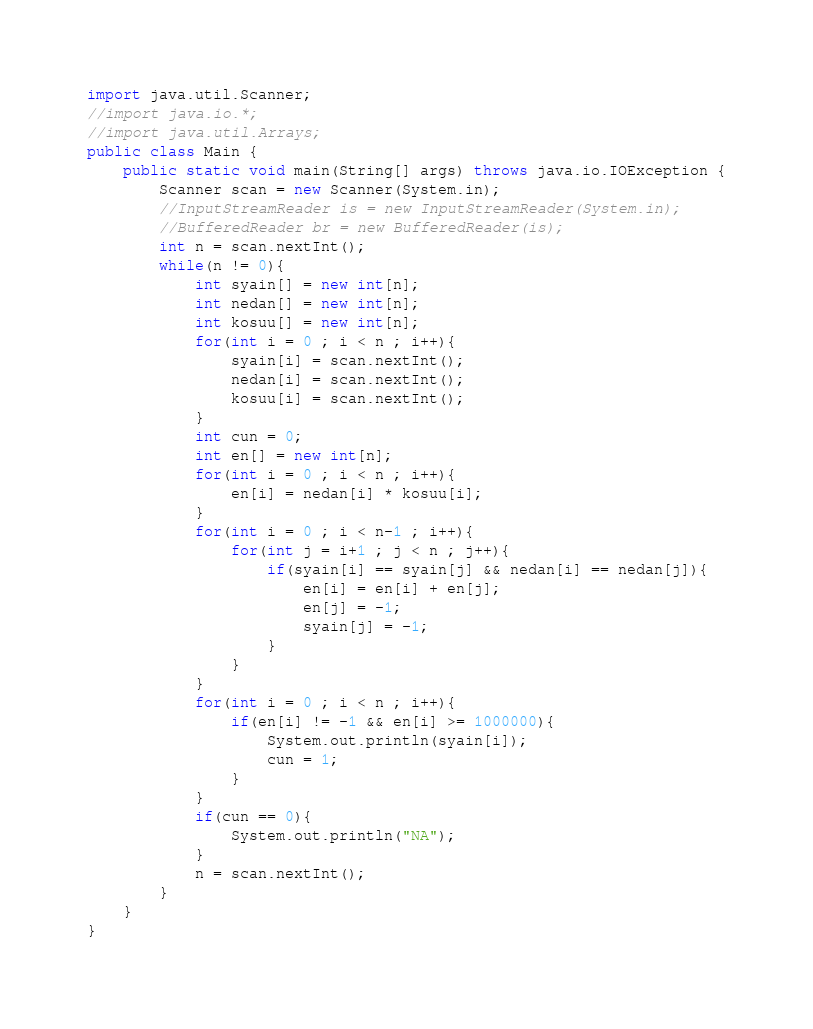<code> <loc_0><loc_0><loc_500><loc_500><_Java_>import java.util.Scanner;
//import java.io.*;
//import java.util.Arrays;
public class Main {
	public static void main(String[] args) throws java.io.IOException {
		Scanner scan = new Scanner(System.in);
		//InputStreamReader is = new InputStreamReader(System.in);
		//BufferedReader br = new BufferedReader(is);
		int n = scan.nextInt();
		while(n != 0){
			int syain[] = new int[n];
			int nedan[] = new int[n];
			int kosuu[] = new int[n];
			for(int i = 0 ; i < n ; i++){
				syain[i] = scan.nextInt();
				nedan[i] = scan.nextInt();
				kosuu[i] = scan.nextInt();
			}
			int cun = 0;
			int en[] = new int[n];
			for(int i = 0 ; i < n ; i++){
				en[i] = nedan[i] * kosuu[i];
			}
			for(int i = 0 ; i < n-1 ; i++){
				for(int j = i+1 ; j < n ; j++){
					if(syain[i] == syain[j] && nedan[i] == nedan[j]){
						en[i] = en[i] + en[j];
						en[j] = -1;
						syain[j] = -1;
					}
				}
			}
			for(int i = 0 ; i < n ; i++){
				if(en[i] != -1 && en[i] >= 1000000){
					System.out.println(syain[i]);
					cun = 1;
				}
			}
			if(cun == 0){
				System.out.println("NA");
			}
			n = scan.nextInt();
		}
	}
}</code> 